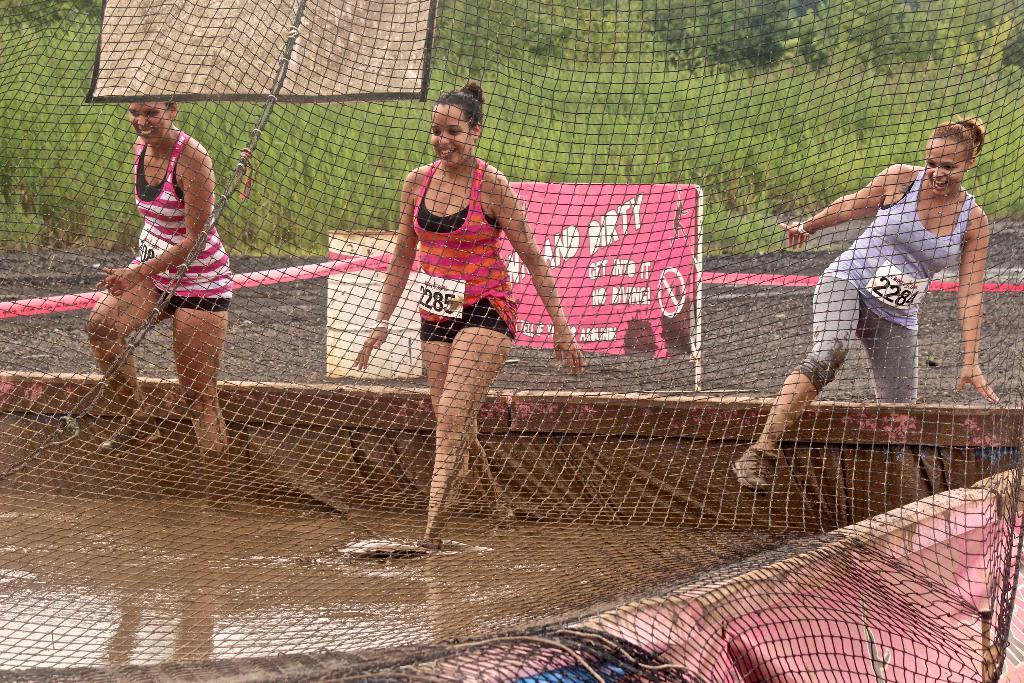<image>
Present a compact description of the photo's key features. A women wearing a tag that has the numbers 2285 on it. 